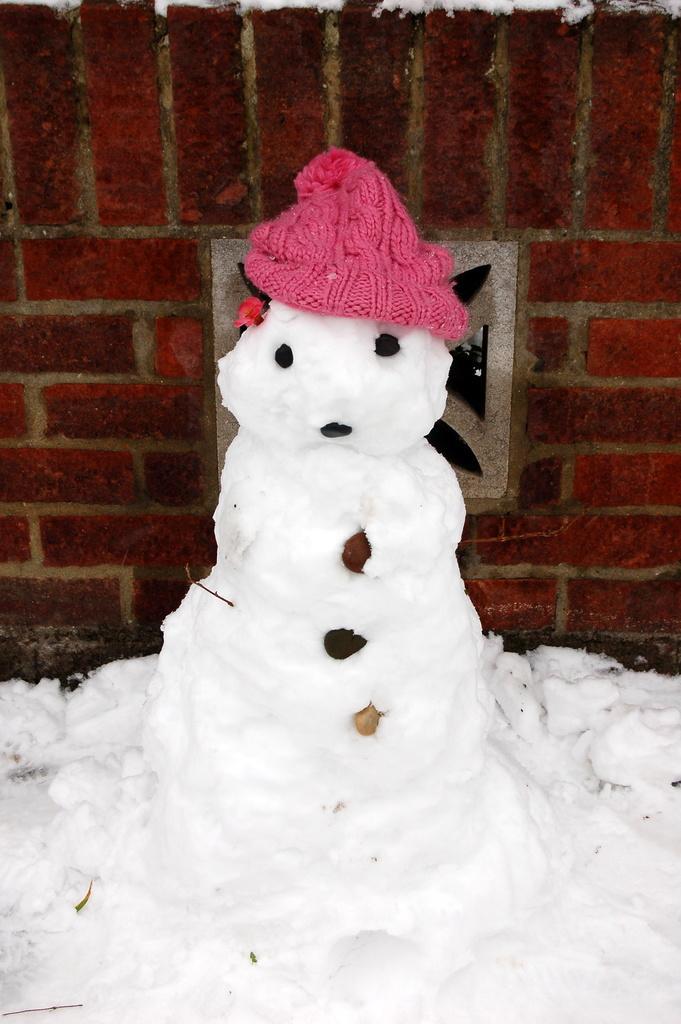Could you give a brief overview of what you see in this image? In the middle of the picture, we see the snowman with pink color cap. At the bottom of the picture, we see ice. In the background, we see a red color wall which is made up of bricks. 